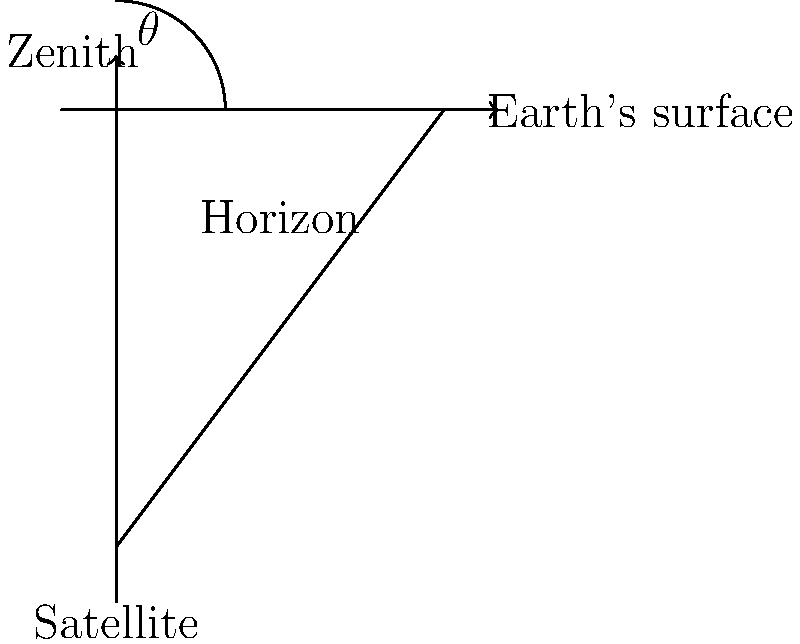In aligning a satellite dish for optimal global communication, what is the ideal elevation angle $\theta$ (in degrees) for a geostationary satellite positioned directly above the equator, as viewed from a ground station located at 45° latitude? To determine the optimal elevation angle for a satellite dish, we need to follow these steps:

1) Geostationary satellites orbit the Earth above the equator at an altitude of approximately 35,786 km.

2) The Earth's radius is approximately 6,371 km.

3) For a ground station at 45° latitude, we can use the following formula to calculate the elevation angle:

   $$\theta = \arctan(\frac{\cos\phi - \frac{R_e}{R_s}}{\sin\phi})$$

   Where:
   $\theta$ is the elevation angle
   $\phi$ is the latitude of the ground station
   $R_e$ is the Earth's radius
   $R_s$ is the orbital radius of the satellite (Earth's radius + satellite altitude)

4) Let's substitute the values:
   $\phi = 45°$
   $R_e = 6,371$ km
   $R_s = 6,371 + 35,786 = 42,157$ km

5) Now, let's calculate:
   $$\theta = \arctan(\frac{\cos(45°) - \frac{6,371}{42,157}}{\sin(45°)})$$

6) Simplifying:
   $$\theta = \arctan(\frac{0.7071 - 0.1511}{0.7071})$$
   $$\theta = \arctan(0.7859)$$

7) Calculating the final result:
   $$\theta \approx 38.08°$$

Therefore, the optimal elevation angle for the satellite dish is approximately 38.08°.
Answer: 38.08° 